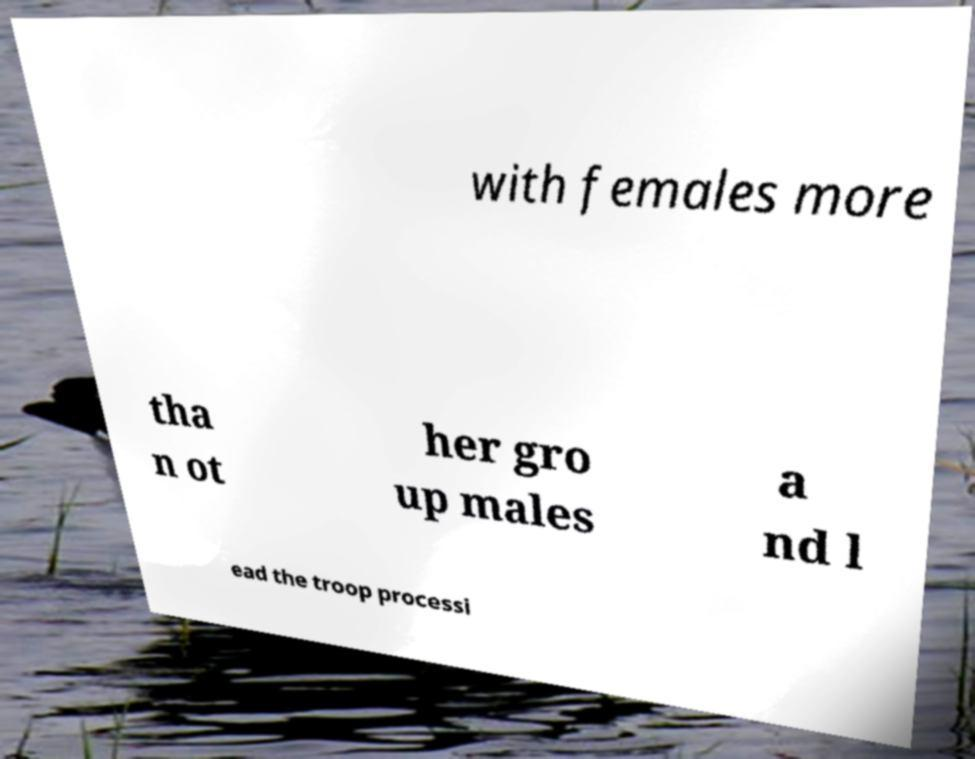Can you accurately transcribe the text from the provided image for me? with females more tha n ot her gro up males a nd l ead the troop processi 